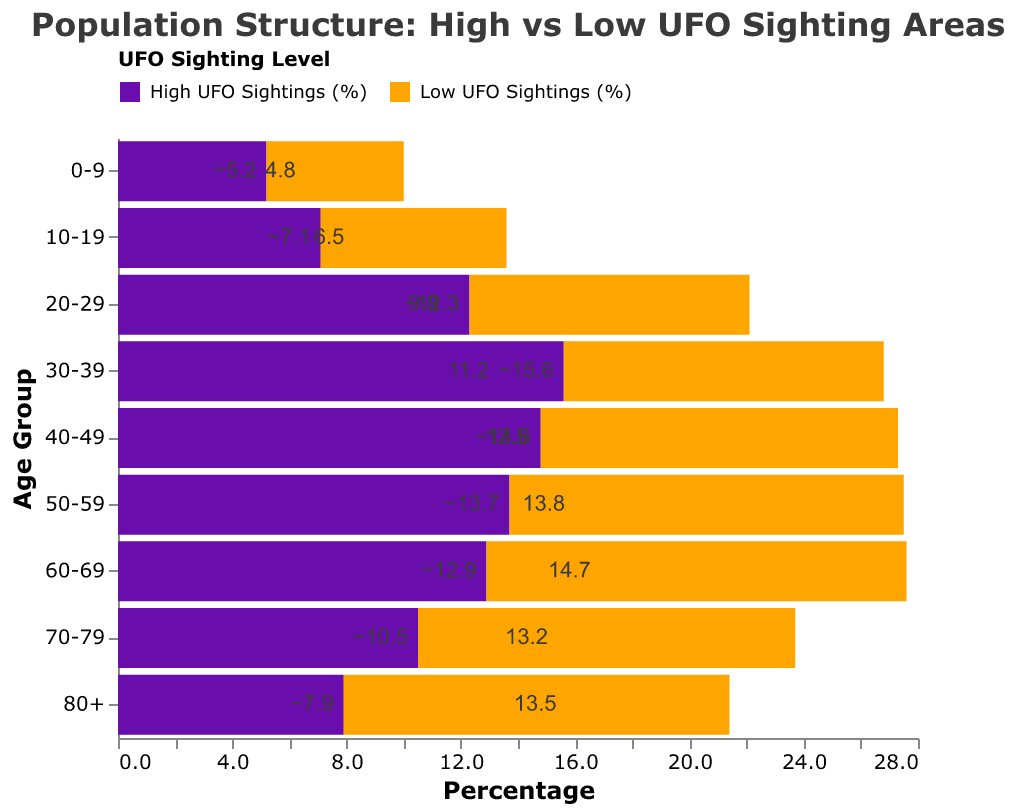What's the title of the chart? The title of the chart is located at the top and it typically describes the main subject of the figure. In this case, it reads: "Population Structure: High vs Low UFO Sighting Areas".
Answer: Population Structure: High vs Low UFO Sighting Areas What age group has the highest percentage in the Low UFO Sightings area? From the data, the highest percentage in the Low UFO Sightings areas is marked with the 80+ age group, having a percentage of 13.5%
Answer: 80+ Which color represents the areas with High UFO Sightings? The legend at the top of the chart tells us that the color purple represents "High UFO Sightings (%)".
Answer: Purple What is the percentage for the 30-39 age group in areas with Low UFO Sightings? The chart indicates that for the 30-39 age group in the Low UFO Sightings area, the percentage is 11.2%.
Answer: 11.2% How much greater is the percentage for the 50-59 age group in Low UFO Sighting areas compared to High UFO Sighting areas? The percentage for the 50-59 age group in Low UFO Sighting areas is 13.8%. In High UFO Sighting areas, it is -13.7%. The overall difference is calculated as 13.8 + 13.7 = 27.5%.
Answer: 27.5% What can you infer from comparing the percentages of the 60-69 age group in both sighting areas? The percentage of the 60-69 age group in Low UFO Sighting areas is higher (14.7%) compared to High UFO Sighting areas (-12.9%), indicating a higher concentration of this age group in Low UFO Sighting areas.
Answer: Higher in Low Sighting Areas How do the percentages for the 0-9 age group compare between High and Low UFO Sighting areas? The percentage of the 0-9 age group is 4.8% in Low UFO Sighting areas and -5.2% in High UFO Sighting areas. The comparison reveals that the percentage is higher in Low UFO Sighting areas.
Answer: Higher in Low Sighting Areas What overall trend does the chart suggest about the age distribution in High vs Low UFO Sighting areas? The chart visually displays that Low UFO Sighting areas have comparatively higher percentages across all age groups, whereas High UFO Sighting areas show negative values, suggesting a lower population or higher out-migration rate in those areas.
Answer: Higher percentages in Low Sighting Areas across all age groups 